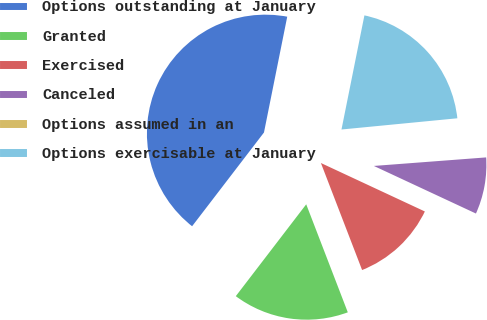<chart> <loc_0><loc_0><loc_500><loc_500><pie_chart><fcel>Options outstanding at January<fcel>Granted<fcel>Exercised<fcel>Canceled<fcel>Options assumed in an<fcel>Options exercisable at January<nl><fcel>42.75%<fcel>16.26%<fcel>12.21%<fcel>8.15%<fcel>0.33%<fcel>20.31%<nl></chart> 